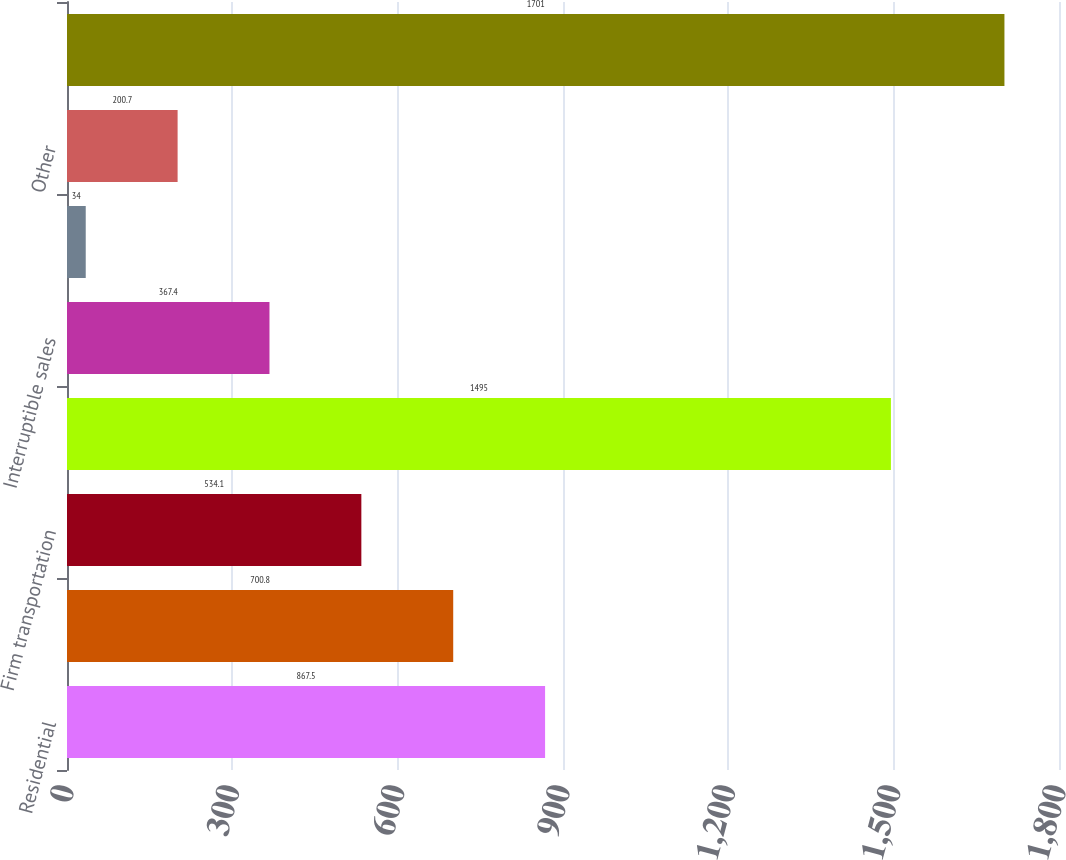Convert chart to OTSL. <chart><loc_0><loc_0><loc_500><loc_500><bar_chart><fcel>Residential<fcel>General<fcel>Firm transportation<fcel>Total firm sales and<fcel>Interruptible sales<fcel>Generation plants<fcel>Other<fcel>Total<nl><fcel>867.5<fcel>700.8<fcel>534.1<fcel>1495<fcel>367.4<fcel>34<fcel>200.7<fcel>1701<nl></chart> 